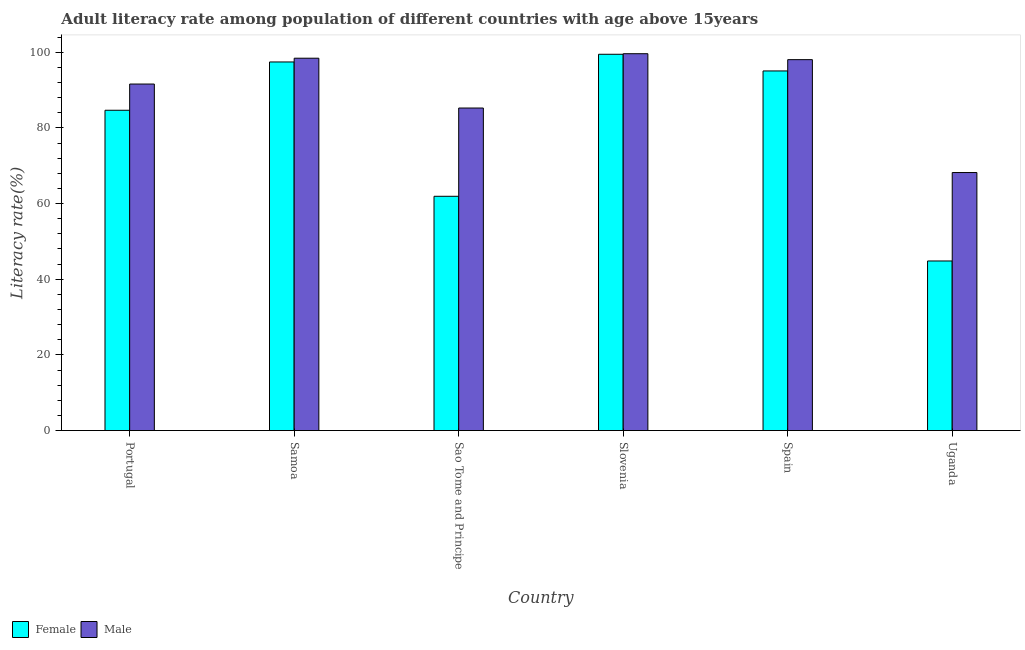Are the number of bars per tick equal to the number of legend labels?
Your answer should be very brief. Yes. Are the number of bars on each tick of the X-axis equal?
Your answer should be very brief. Yes. What is the label of the 4th group of bars from the left?
Ensure brevity in your answer.  Slovenia. In how many cases, is the number of bars for a given country not equal to the number of legend labels?
Your response must be concise. 0. What is the female adult literacy rate in Uganda?
Provide a succinct answer. 44.83. Across all countries, what is the maximum male adult literacy rate?
Your answer should be very brief. 99.6. Across all countries, what is the minimum male adult literacy rate?
Offer a very short reply. 68.2. In which country was the male adult literacy rate maximum?
Your response must be concise. Slovenia. In which country was the female adult literacy rate minimum?
Offer a terse response. Uganda. What is the total female adult literacy rate in the graph?
Your answer should be compact. 483.33. What is the difference between the female adult literacy rate in Portugal and that in Uganda?
Keep it short and to the point. 39.83. What is the difference between the female adult literacy rate in Samoa and the male adult literacy rate in Sao Tome and Principe?
Keep it short and to the point. 12.17. What is the average female adult literacy rate per country?
Your answer should be very brief. 80.56. What is the difference between the female adult literacy rate and male adult literacy rate in Portugal?
Provide a succinct answer. -6.93. In how many countries, is the female adult literacy rate greater than 80 %?
Give a very brief answer. 4. What is the ratio of the male adult literacy rate in Samoa to that in Spain?
Keep it short and to the point. 1. What is the difference between the highest and the second highest female adult literacy rate?
Provide a succinct answer. 2.03. What is the difference between the highest and the lowest male adult literacy rate?
Provide a succinct answer. 31.4. Is the sum of the female adult literacy rate in Sao Tome and Principe and Spain greater than the maximum male adult literacy rate across all countries?
Provide a short and direct response. Yes. Are all the bars in the graph horizontal?
Your answer should be very brief. No. What is the difference between two consecutive major ticks on the Y-axis?
Your response must be concise. 20. Does the graph contain grids?
Offer a very short reply. No. Where does the legend appear in the graph?
Your answer should be compact. Bottom left. How many legend labels are there?
Give a very brief answer. 2. What is the title of the graph?
Offer a terse response. Adult literacy rate among population of different countries with age above 15years. What is the label or title of the X-axis?
Keep it short and to the point. Country. What is the label or title of the Y-axis?
Offer a very short reply. Literacy rate(%). What is the Literacy rate(%) of Female in Portugal?
Your answer should be compact. 84.66. What is the Literacy rate(%) of Male in Portugal?
Provide a succinct answer. 91.59. What is the Literacy rate(%) of Female in Samoa?
Keep it short and to the point. 97.42. What is the Literacy rate(%) of Male in Samoa?
Give a very brief answer. 98.42. What is the Literacy rate(%) of Female in Sao Tome and Principe?
Your response must be concise. 61.92. What is the Literacy rate(%) in Male in Sao Tome and Principe?
Ensure brevity in your answer.  85.25. What is the Literacy rate(%) of Female in Slovenia?
Offer a terse response. 99.45. What is the Literacy rate(%) of Male in Slovenia?
Your response must be concise. 99.6. What is the Literacy rate(%) of Female in Spain?
Provide a short and direct response. 95.05. What is the Literacy rate(%) in Male in Spain?
Offer a terse response. 98.04. What is the Literacy rate(%) of Female in Uganda?
Make the answer very short. 44.83. What is the Literacy rate(%) of Male in Uganda?
Your answer should be very brief. 68.2. Across all countries, what is the maximum Literacy rate(%) of Female?
Give a very brief answer. 99.45. Across all countries, what is the maximum Literacy rate(%) in Male?
Your answer should be compact. 99.6. Across all countries, what is the minimum Literacy rate(%) of Female?
Make the answer very short. 44.83. Across all countries, what is the minimum Literacy rate(%) of Male?
Offer a very short reply. 68.2. What is the total Literacy rate(%) in Female in the graph?
Give a very brief answer. 483.33. What is the total Literacy rate(%) of Male in the graph?
Offer a very short reply. 541.09. What is the difference between the Literacy rate(%) of Female in Portugal and that in Samoa?
Offer a terse response. -12.76. What is the difference between the Literacy rate(%) in Male in Portugal and that in Samoa?
Provide a short and direct response. -6.83. What is the difference between the Literacy rate(%) in Female in Portugal and that in Sao Tome and Principe?
Offer a terse response. 22.74. What is the difference between the Literacy rate(%) in Male in Portugal and that in Sao Tome and Principe?
Keep it short and to the point. 6.34. What is the difference between the Literacy rate(%) of Female in Portugal and that in Slovenia?
Give a very brief answer. -14.8. What is the difference between the Literacy rate(%) in Male in Portugal and that in Slovenia?
Your answer should be compact. -8.02. What is the difference between the Literacy rate(%) in Female in Portugal and that in Spain?
Give a very brief answer. -10.39. What is the difference between the Literacy rate(%) of Male in Portugal and that in Spain?
Make the answer very short. -6.45. What is the difference between the Literacy rate(%) of Female in Portugal and that in Uganda?
Give a very brief answer. 39.83. What is the difference between the Literacy rate(%) of Male in Portugal and that in Uganda?
Provide a succinct answer. 23.39. What is the difference between the Literacy rate(%) of Female in Samoa and that in Sao Tome and Principe?
Make the answer very short. 35.5. What is the difference between the Literacy rate(%) in Male in Samoa and that in Sao Tome and Principe?
Your answer should be very brief. 13.17. What is the difference between the Literacy rate(%) of Female in Samoa and that in Slovenia?
Give a very brief answer. -2.03. What is the difference between the Literacy rate(%) in Male in Samoa and that in Slovenia?
Your response must be concise. -1.19. What is the difference between the Literacy rate(%) in Female in Samoa and that in Spain?
Offer a very short reply. 2.37. What is the difference between the Literacy rate(%) in Male in Samoa and that in Spain?
Your answer should be very brief. 0.38. What is the difference between the Literacy rate(%) of Female in Samoa and that in Uganda?
Provide a succinct answer. 52.59. What is the difference between the Literacy rate(%) in Male in Samoa and that in Uganda?
Your answer should be compact. 30.22. What is the difference between the Literacy rate(%) of Female in Sao Tome and Principe and that in Slovenia?
Provide a short and direct response. -37.53. What is the difference between the Literacy rate(%) in Male in Sao Tome and Principe and that in Slovenia?
Your response must be concise. -14.35. What is the difference between the Literacy rate(%) of Female in Sao Tome and Principe and that in Spain?
Offer a terse response. -33.13. What is the difference between the Literacy rate(%) of Male in Sao Tome and Principe and that in Spain?
Offer a terse response. -12.79. What is the difference between the Literacy rate(%) in Female in Sao Tome and Principe and that in Uganda?
Your response must be concise. 17.09. What is the difference between the Literacy rate(%) of Male in Sao Tome and Principe and that in Uganda?
Make the answer very short. 17.05. What is the difference between the Literacy rate(%) of Female in Slovenia and that in Spain?
Give a very brief answer. 4.4. What is the difference between the Literacy rate(%) of Male in Slovenia and that in Spain?
Offer a terse response. 1.57. What is the difference between the Literacy rate(%) of Female in Slovenia and that in Uganda?
Your answer should be compact. 54.63. What is the difference between the Literacy rate(%) in Male in Slovenia and that in Uganda?
Provide a short and direct response. 31.4. What is the difference between the Literacy rate(%) of Female in Spain and that in Uganda?
Ensure brevity in your answer.  50.22. What is the difference between the Literacy rate(%) of Male in Spain and that in Uganda?
Your answer should be compact. 29.84. What is the difference between the Literacy rate(%) in Female in Portugal and the Literacy rate(%) in Male in Samoa?
Provide a short and direct response. -13.76. What is the difference between the Literacy rate(%) of Female in Portugal and the Literacy rate(%) of Male in Sao Tome and Principe?
Provide a succinct answer. -0.59. What is the difference between the Literacy rate(%) in Female in Portugal and the Literacy rate(%) in Male in Slovenia?
Your answer should be compact. -14.94. What is the difference between the Literacy rate(%) of Female in Portugal and the Literacy rate(%) of Male in Spain?
Make the answer very short. -13.38. What is the difference between the Literacy rate(%) in Female in Portugal and the Literacy rate(%) in Male in Uganda?
Make the answer very short. 16.46. What is the difference between the Literacy rate(%) of Female in Samoa and the Literacy rate(%) of Male in Sao Tome and Principe?
Your answer should be very brief. 12.17. What is the difference between the Literacy rate(%) in Female in Samoa and the Literacy rate(%) in Male in Slovenia?
Your answer should be compact. -2.18. What is the difference between the Literacy rate(%) of Female in Samoa and the Literacy rate(%) of Male in Spain?
Make the answer very short. -0.61. What is the difference between the Literacy rate(%) of Female in Samoa and the Literacy rate(%) of Male in Uganda?
Your answer should be compact. 29.22. What is the difference between the Literacy rate(%) of Female in Sao Tome and Principe and the Literacy rate(%) of Male in Slovenia?
Offer a very short reply. -37.68. What is the difference between the Literacy rate(%) in Female in Sao Tome and Principe and the Literacy rate(%) in Male in Spain?
Make the answer very short. -36.12. What is the difference between the Literacy rate(%) in Female in Sao Tome and Principe and the Literacy rate(%) in Male in Uganda?
Your answer should be very brief. -6.28. What is the difference between the Literacy rate(%) in Female in Slovenia and the Literacy rate(%) in Male in Spain?
Provide a succinct answer. 1.42. What is the difference between the Literacy rate(%) in Female in Slovenia and the Literacy rate(%) in Male in Uganda?
Make the answer very short. 31.26. What is the difference between the Literacy rate(%) of Female in Spain and the Literacy rate(%) of Male in Uganda?
Your response must be concise. 26.85. What is the average Literacy rate(%) in Female per country?
Your answer should be compact. 80.56. What is the average Literacy rate(%) in Male per country?
Offer a very short reply. 90.18. What is the difference between the Literacy rate(%) of Female and Literacy rate(%) of Male in Portugal?
Your answer should be compact. -6.93. What is the difference between the Literacy rate(%) of Female and Literacy rate(%) of Male in Samoa?
Provide a short and direct response. -0.99. What is the difference between the Literacy rate(%) of Female and Literacy rate(%) of Male in Sao Tome and Principe?
Give a very brief answer. -23.33. What is the difference between the Literacy rate(%) in Female and Literacy rate(%) in Male in Slovenia?
Provide a succinct answer. -0.15. What is the difference between the Literacy rate(%) in Female and Literacy rate(%) in Male in Spain?
Keep it short and to the point. -2.98. What is the difference between the Literacy rate(%) of Female and Literacy rate(%) of Male in Uganda?
Ensure brevity in your answer.  -23.37. What is the ratio of the Literacy rate(%) in Female in Portugal to that in Samoa?
Offer a terse response. 0.87. What is the ratio of the Literacy rate(%) in Male in Portugal to that in Samoa?
Keep it short and to the point. 0.93. What is the ratio of the Literacy rate(%) in Female in Portugal to that in Sao Tome and Principe?
Provide a short and direct response. 1.37. What is the ratio of the Literacy rate(%) in Male in Portugal to that in Sao Tome and Principe?
Ensure brevity in your answer.  1.07. What is the ratio of the Literacy rate(%) in Female in Portugal to that in Slovenia?
Make the answer very short. 0.85. What is the ratio of the Literacy rate(%) of Male in Portugal to that in Slovenia?
Provide a short and direct response. 0.92. What is the ratio of the Literacy rate(%) of Female in Portugal to that in Spain?
Make the answer very short. 0.89. What is the ratio of the Literacy rate(%) of Male in Portugal to that in Spain?
Your response must be concise. 0.93. What is the ratio of the Literacy rate(%) of Female in Portugal to that in Uganda?
Keep it short and to the point. 1.89. What is the ratio of the Literacy rate(%) in Male in Portugal to that in Uganda?
Provide a short and direct response. 1.34. What is the ratio of the Literacy rate(%) of Female in Samoa to that in Sao Tome and Principe?
Your response must be concise. 1.57. What is the ratio of the Literacy rate(%) in Male in Samoa to that in Sao Tome and Principe?
Offer a terse response. 1.15. What is the ratio of the Literacy rate(%) of Female in Samoa to that in Slovenia?
Keep it short and to the point. 0.98. What is the ratio of the Literacy rate(%) in Female in Samoa to that in Spain?
Your answer should be very brief. 1.02. What is the ratio of the Literacy rate(%) in Female in Samoa to that in Uganda?
Your answer should be compact. 2.17. What is the ratio of the Literacy rate(%) in Male in Samoa to that in Uganda?
Keep it short and to the point. 1.44. What is the ratio of the Literacy rate(%) in Female in Sao Tome and Principe to that in Slovenia?
Make the answer very short. 0.62. What is the ratio of the Literacy rate(%) of Male in Sao Tome and Principe to that in Slovenia?
Provide a short and direct response. 0.86. What is the ratio of the Literacy rate(%) of Female in Sao Tome and Principe to that in Spain?
Offer a very short reply. 0.65. What is the ratio of the Literacy rate(%) of Male in Sao Tome and Principe to that in Spain?
Your response must be concise. 0.87. What is the ratio of the Literacy rate(%) of Female in Sao Tome and Principe to that in Uganda?
Provide a succinct answer. 1.38. What is the ratio of the Literacy rate(%) of Male in Sao Tome and Principe to that in Uganda?
Your answer should be compact. 1.25. What is the ratio of the Literacy rate(%) in Female in Slovenia to that in Spain?
Make the answer very short. 1.05. What is the ratio of the Literacy rate(%) in Male in Slovenia to that in Spain?
Make the answer very short. 1.02. What is the ratio of the Literacy rate(%) of Female in Slovenia to that in Uganda?
Keep it short and to the point. 2.22. What is the ratio of the Literacy rate(%) of Male in Slovenia to that in Uganda?
Your response must be concise. 1.46. What is the ratio of the Literacy rate(%) in Female in Spain to that in Uganda?
Provide a succinct answer. 2.12. What is the ratio of the Literacy rate(%) in Male in Spain to that in Uganda?
Provide a succinct answer. 1.44. What is the difference between the highest and the second highest Literacy rate(%) in Female?
Your answer should be compact. 2.03. What is the difference between the highest and the second highest Literacy rate(%) in Male?
Provide a succinct answer. 1.19. What is the difference between the highest and the lowest Literacy rate(%) in Female?
Provide a succinct answer. 54.63. What is the difference between the highest and the lowest Literacy rate(%) in Male?
Your answer should be compact. 31.4. 